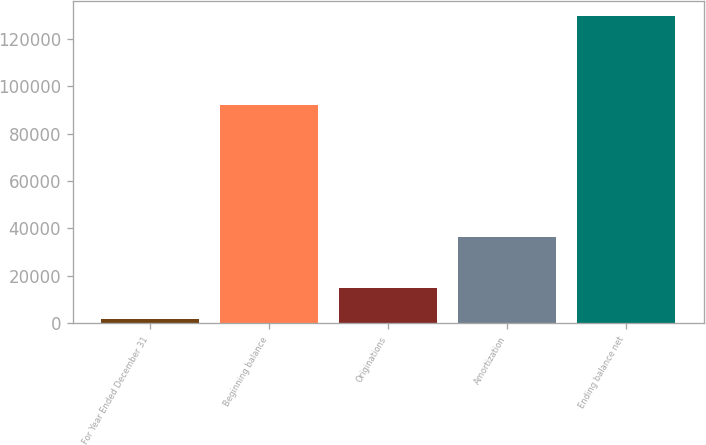<chart> <loc_0><loc_0><loc_500><loc_500><bar_chart><fcel>For Year Ended December 31<fcel>Beginning balance<fcel>Originations<fcel>Amortization<fcel>Ending balance net<nl><fcel>2011<fcel>92066<fcel>14756.3<fcel>36364<fcel>129464<nl></chart> 